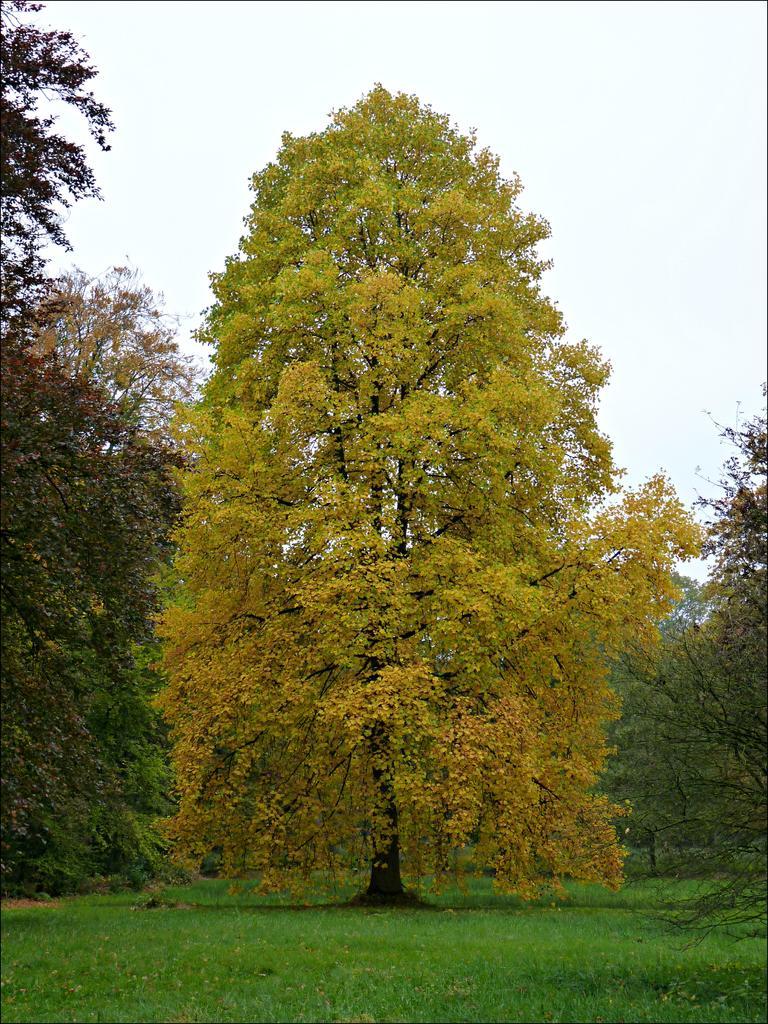Describe this image in one or two sentences. In this image we can see some trees, grass, and also we can see the sky. 